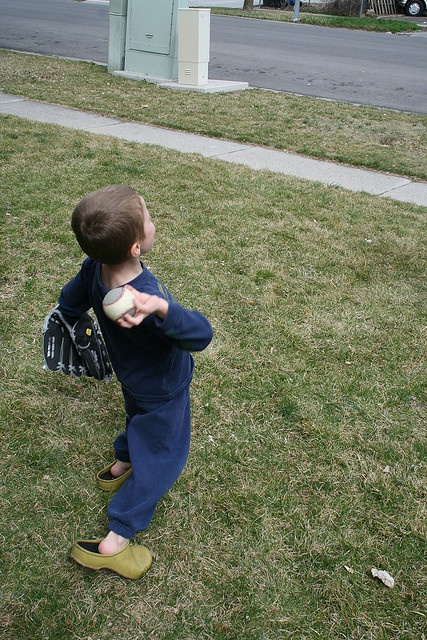Describe the objects in this image and their specific colors. I can see people in gray, black, navy, and olive tones, baseball glove in gray, black, darkgray, and blue tones, and sports ball in gray, ivory, and darkgray tones in this image. 